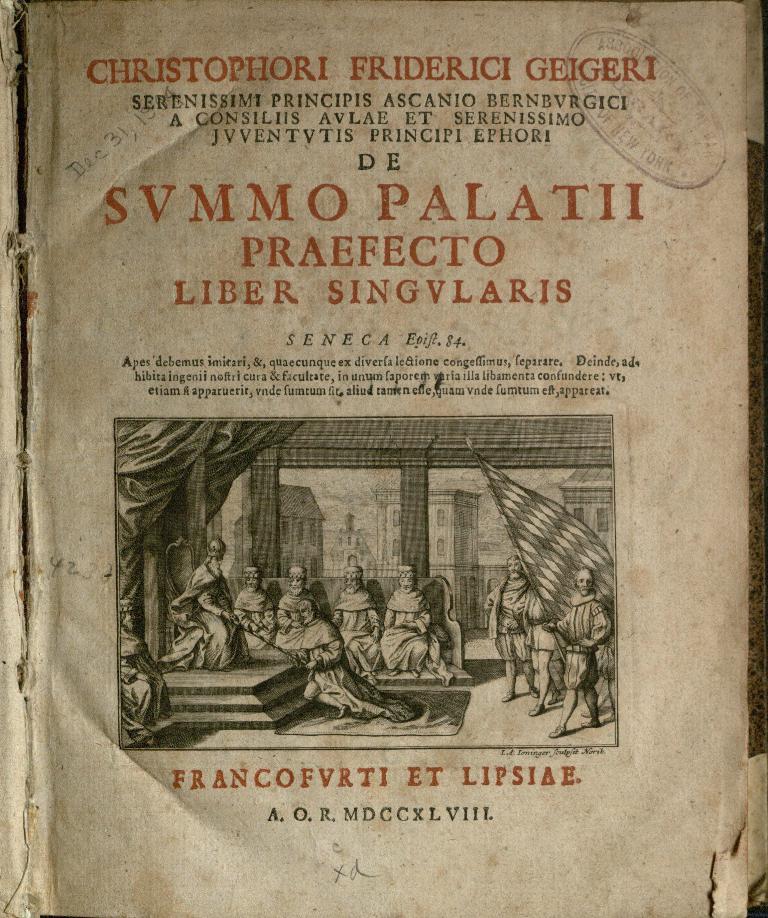What is the first name of the person listed on the top of the page?
Provide a succinct answer. Christophori. What is written on the bottom line of text?
Make the answer very short. A.o.r. mdccxlviil. 